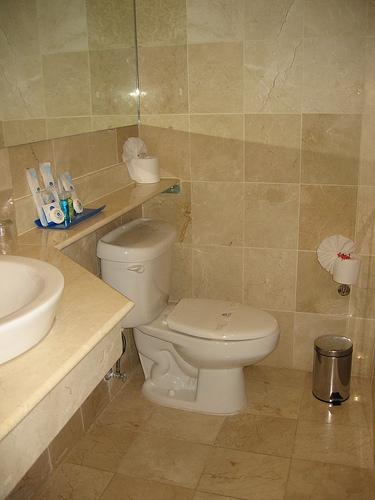Describe the setting of the image as a location for a scene. The luxurious marble hotel bathroom provides a pristine backdrop for the scene, accentuated by gleaming stainless steel accessories and top-notch toiletries. Mention the most striking feature of the image. The stunning marble hotel bathroom exudes luxury with its seamless blend of ornate tilework, sophisticated accessories, and meticulous attention to detail. Mention the main objects in the image and their colors. White toilet, marble tiled walls and floor, silver and black trashcan, white toilet paper, silver knob for toilet, and large bathroom mirror. Compose a sentence focusing on the main item in the bathroom. The pristine white porcelain toilet sits regally in the hotel bathroom, complemented by sophisticated marble tiles and elegant accessories. Write a sentence describing the overall atmosphere of the image. The picture showcases a pristine and luxurious hotel bathroom filled with various items, displaying an air of sophistication and attentiveness. Provide a brief description of the scene present in the image. A well-maintained upscale hotel bathroom with white porcelain toilet, marble tiled walls and floor, and various toiletries on a counter. Create a short and descriptive sentence about the image. An exquisite hotel bathroom boasts a white porcelain toilet, marble tile accents, and a generous assortment of carefully presented toiletries. Describe the featured bathroom accessory in the image. The eye-catching fliptop trash can has a silver and black design, seamlessly fitting in with the elegant and upscale theme of the hotel bathroom. Narrate the image as a part of a story setting. As she entered the opulent hotel bathroom, her eyes were instantly drawn to the white porcelain toilet, marble tiles, and neatly arranged toiletries awaiting her use. List the objects found on the bathroom counter. Tray of hotel bathroom toiletries, disposable drinking cups, personal grooming items, small bar of soap on a blue holder, and an assortment of toiletries. 